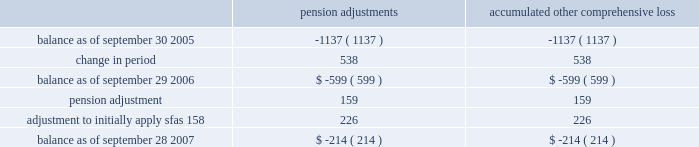In september 2006 , the fasb issued sfas 158 , 201cemployers 2019 accounting for defined benefit pension and other postretirement plans , an amendment of fasb statements no .
87 , 88 , 106 , and 132 ( r ) . 201d sfas 158 requires companies to recognize the over-funded and under-funded status of defined benefit pension and other postretire- ment plans as assets or liabilities on their balance sheets .
In addition , changes in the funded status must be recognized through other comprehensive income in shareholders 2019 equity in the year in which the changes occur .
We adopted sfas 158 on september 28 , 2007 .
In accordance with the transition rules in sfas 158 , this standard is being adopted on a prospective basis .
The adoption of sfas 158 resulted in an immaterial adjustment to our balance sheet , and had no impact on our net earnings or cash flows .
Comprehensive income ( loss ) the company accounts for comprehensive income ( loss ) in accordance with the provisions of sfas no .
130 , 201creporting comprehensive income 201d ( 201csfas no .
130 201d ) .
Sfas no .
130 is a financial statement presentation standard that requires the company to disclose non-owner changes included in equity but not included in net income or loss .
Accumulated comprehensive loss presented in the financial statements consists of adjustments to the company 2019s minimum pension liability as follows ( in thousands ) : pension adjustments accumulated comprehensive .
Recently issued accounting pronouncements fin 48 in july 2006 , the fasb issued fasb interpretation no .
48 , 201caccounting for uncertainty in income taxes 2014 an interpretation of fasb statement no .
109 201d ( fin 48 ) , which clarifies the accounting and disclosure for uncertainty in tax positions , as defined .
Fin 48 seeks to reduce the diversity in practice associated with certain aspects of the recognition and measurement related to accounting for income taxes .
This interpretation is effective for fiscal years beginning after december 15 , 2006 , and is therefore effective for the company in fiscal year 2008 .
We are currently evaluating the impact that adopting fin 48 will have on the company 2019s financial position and results of operations , however at this time the company does not expect the impact to materially affect its results from operations or financial position .
Sfas 157 in september 2006 , the fasb issued sfas no .
157 , 201cfair value measurements 201d ( 201csfas 157 201d ) which defines fair value , establishes a framework for measuring fair value in generally accepted accounting principles and expands disclosures about fair value measurements .
Sfas 157 is effective for financial statements issued for fiscal years beginning after november 15 , 2007 and interim periods within those fiscal years .
The company has not yet determined the impact that sfas 157 will have on its results from operations or financial position .
Sab 108 in september 2006 , the securities and exchange commission issued staff accounting bulletin no .
108 , 201cconsidering the effects of prior year misstatements when quantifying misstatements in current year financial statements 201d ( 201csab 108 201d ) , which provides interpretive guidance on how the effects of the carryover or reversal of skyworks solutions , inc .
2007 annual report .
Notes to consolidated financial statements 2014 ( continued ) .
What is the net change in pension liability balance from september 2005 to september 2007? 
Computations: (-214 - -1137)
Answer: 923.0. In september 2006 , the fasb issued sfas 158 , 201cemployers 2019 accounting for defined benefit pension and other postretirement plans , an amendment of fasb statements no .
87 , 88 , 106 , and 132 ( r ) . 201d sfas 158 requires companies to recognize the over-funded and under-funded status of defined benefit pension and other postretire- ment plans as assets or liabilities on their balance sheets .
In addition , changes in the funded status must be recognized through other comprehensive income in shareholders 2019 equity in the year in which the changes occur .
We adopted sfas 158 on september 28 , 2007 .
In accordance with the transition rules in sfas 158 , this standard is being adopted on a prospective basis .
The adoption of sfas 158 resulted in an immaterial adjustment to our balance sheet , and had no impact on our net earnings or cash flows .
Comprehensive income ( loss ) the company accounts for comprehensive income ( loss ) in accordance with the provisions of sfas no .
130 , 201creporting comprehensive income 201d ( 201csfas no .
130 201d ) .
Sfas no .
130 is a financial statement presentation standard that requires the company to disclose non-owner changes included in equity but not included in net income or loss .
Accumulated comprehensive loss presented in the financial statements consists of adjustments to the company 2019s minimum pension liability as follows ( in thousands ) : pension adjustments accumulated comprehensive .
Recently issued accounting pronouncements fin 48 in july 2006 , the fasb issued fasb interpretation no .
48 , 201caccounting for uncertainty in income taxes 2014 an interpretation of fasb statement no .
109 201d ( fin 48 ) , which clarifies the accounting and disclosure for uncertainty in tax positions , as defined .
Fin 48 seeks to reduce the diversity in practice associated with certain aspects of the recognition and measurement related to accounting for income taxes .
This interpretation is effective for fiscal years beginning after december 15 , 2006 , and is therefore effective for the company in fiscal year 2008 .
We are currently evaluating the impact that adopting fin 48 will have on the company 2019s financial position and results of operations , however at this time the company does not expect the impact to materially affect its results from operations or financial position .
Sfas 157 in september 2006 , the fasb issued sfas no .
157 , 201cfair value measurements 201d ( 201csfas 157 201d ) which defines fair value , establishes a framework for measuring fair value in generally accepted accounting principles and expands disclosures about fair value measurements .
Sfas 157 is effective for financial statements issued for fiscal years beginning after november 15 , 2007 and interim periods within those fiscal years .
The company has not yet determined the impact that sfas 157 will have on its results from operations or financial position .
Sab 108 in september 2006 , the securities and exchange commission issued staff accounting bulletin no .
108 , 201cconsidering the effects of prior year misstatements when quantifying misstatements in current year financial statements 201d ( 201csab 108 201d ) , which provides interpretive guidance on how the effects of the carryover or reversal of skyworks solutions , inc .
2007 annual report .
Notes to consolidated financial statements 2014 ( continued ) .
What is the net change in pension liability balance from september 2006 to september 2007? 
Computations: (159 + 226)
Answer: 385.0. 